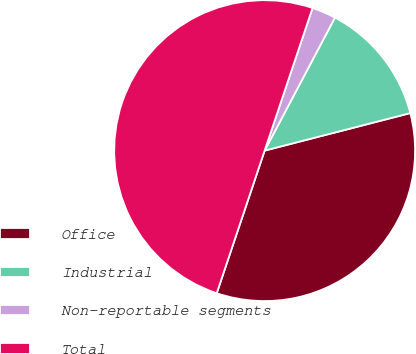Convert chart. <chart><loc_0><loc_0><loc_500><loc_500><pie_chart><fcel>Office<fcel>Industrial<fcel>Non-reportable segments<fcel>Total<nl><fcel>34.17%<fcel>13.25%<fcel>2.58%<fcel>50.0%<nl></chart> 